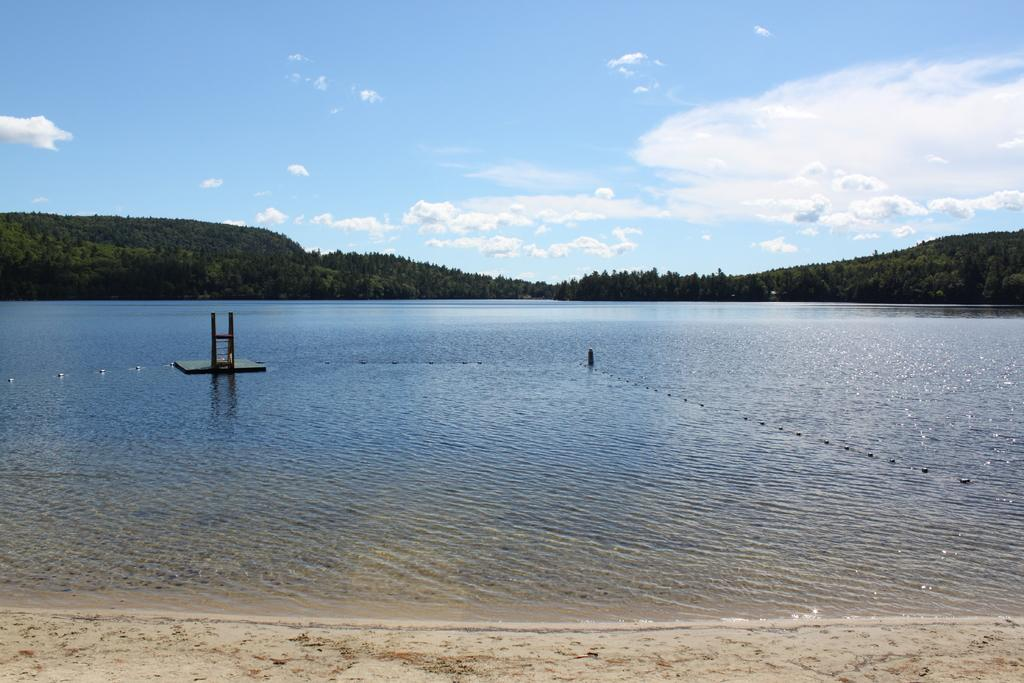What is located in the center of the image? There is water and a pole in the center of the image. What can be seen in the water? There are objects in the water. What is visible in the background of the image? The sky, clouds, hills, and trees are visible in the background of the image. What type of net can be seen smashing into the face of the person in the image? There is no person or net present in the image. What type of face can be seen in the image? There is no face present in the image. 